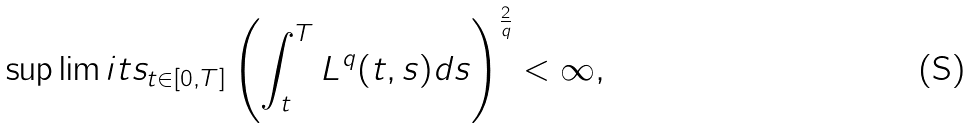Convert formula to latex. <formula><loc_0><loc_0><loc_500><loc_500>\sup \lim i t s _ { t \in [ 0 , T ] } \left ( \int _ { t } ^ { T } L ^ { q } ( t , s ) d s \right ) ^ { \frac { 2 } { q } } < \infty ,</formula> 